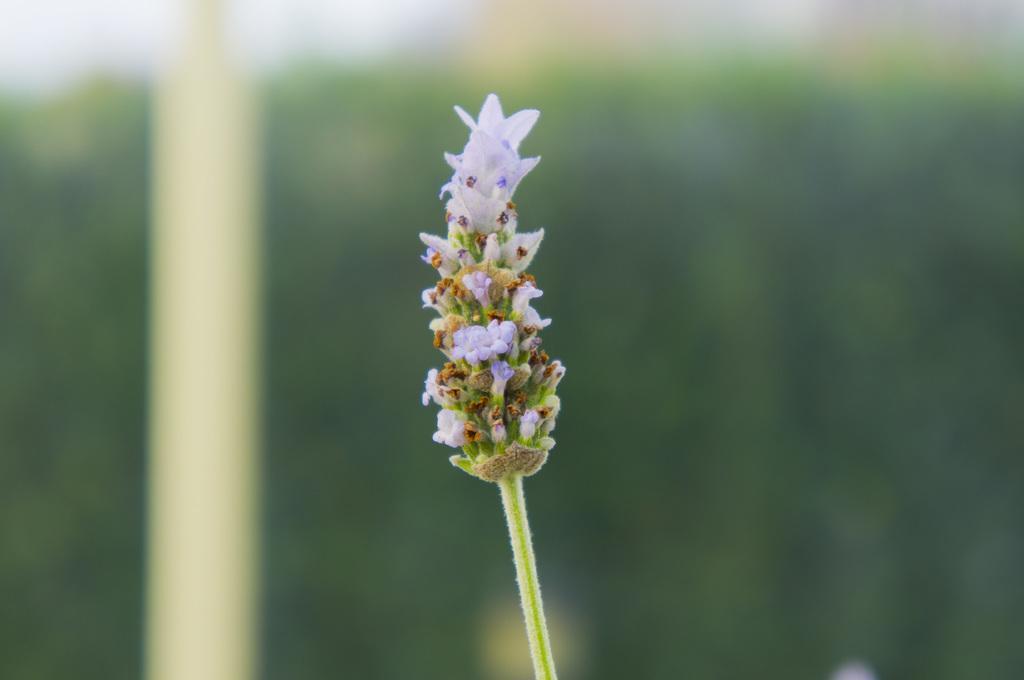In one or two sentences, can you explain what this image depicts? Here I can see few flowers and buds to a stem. The background is blurred. 